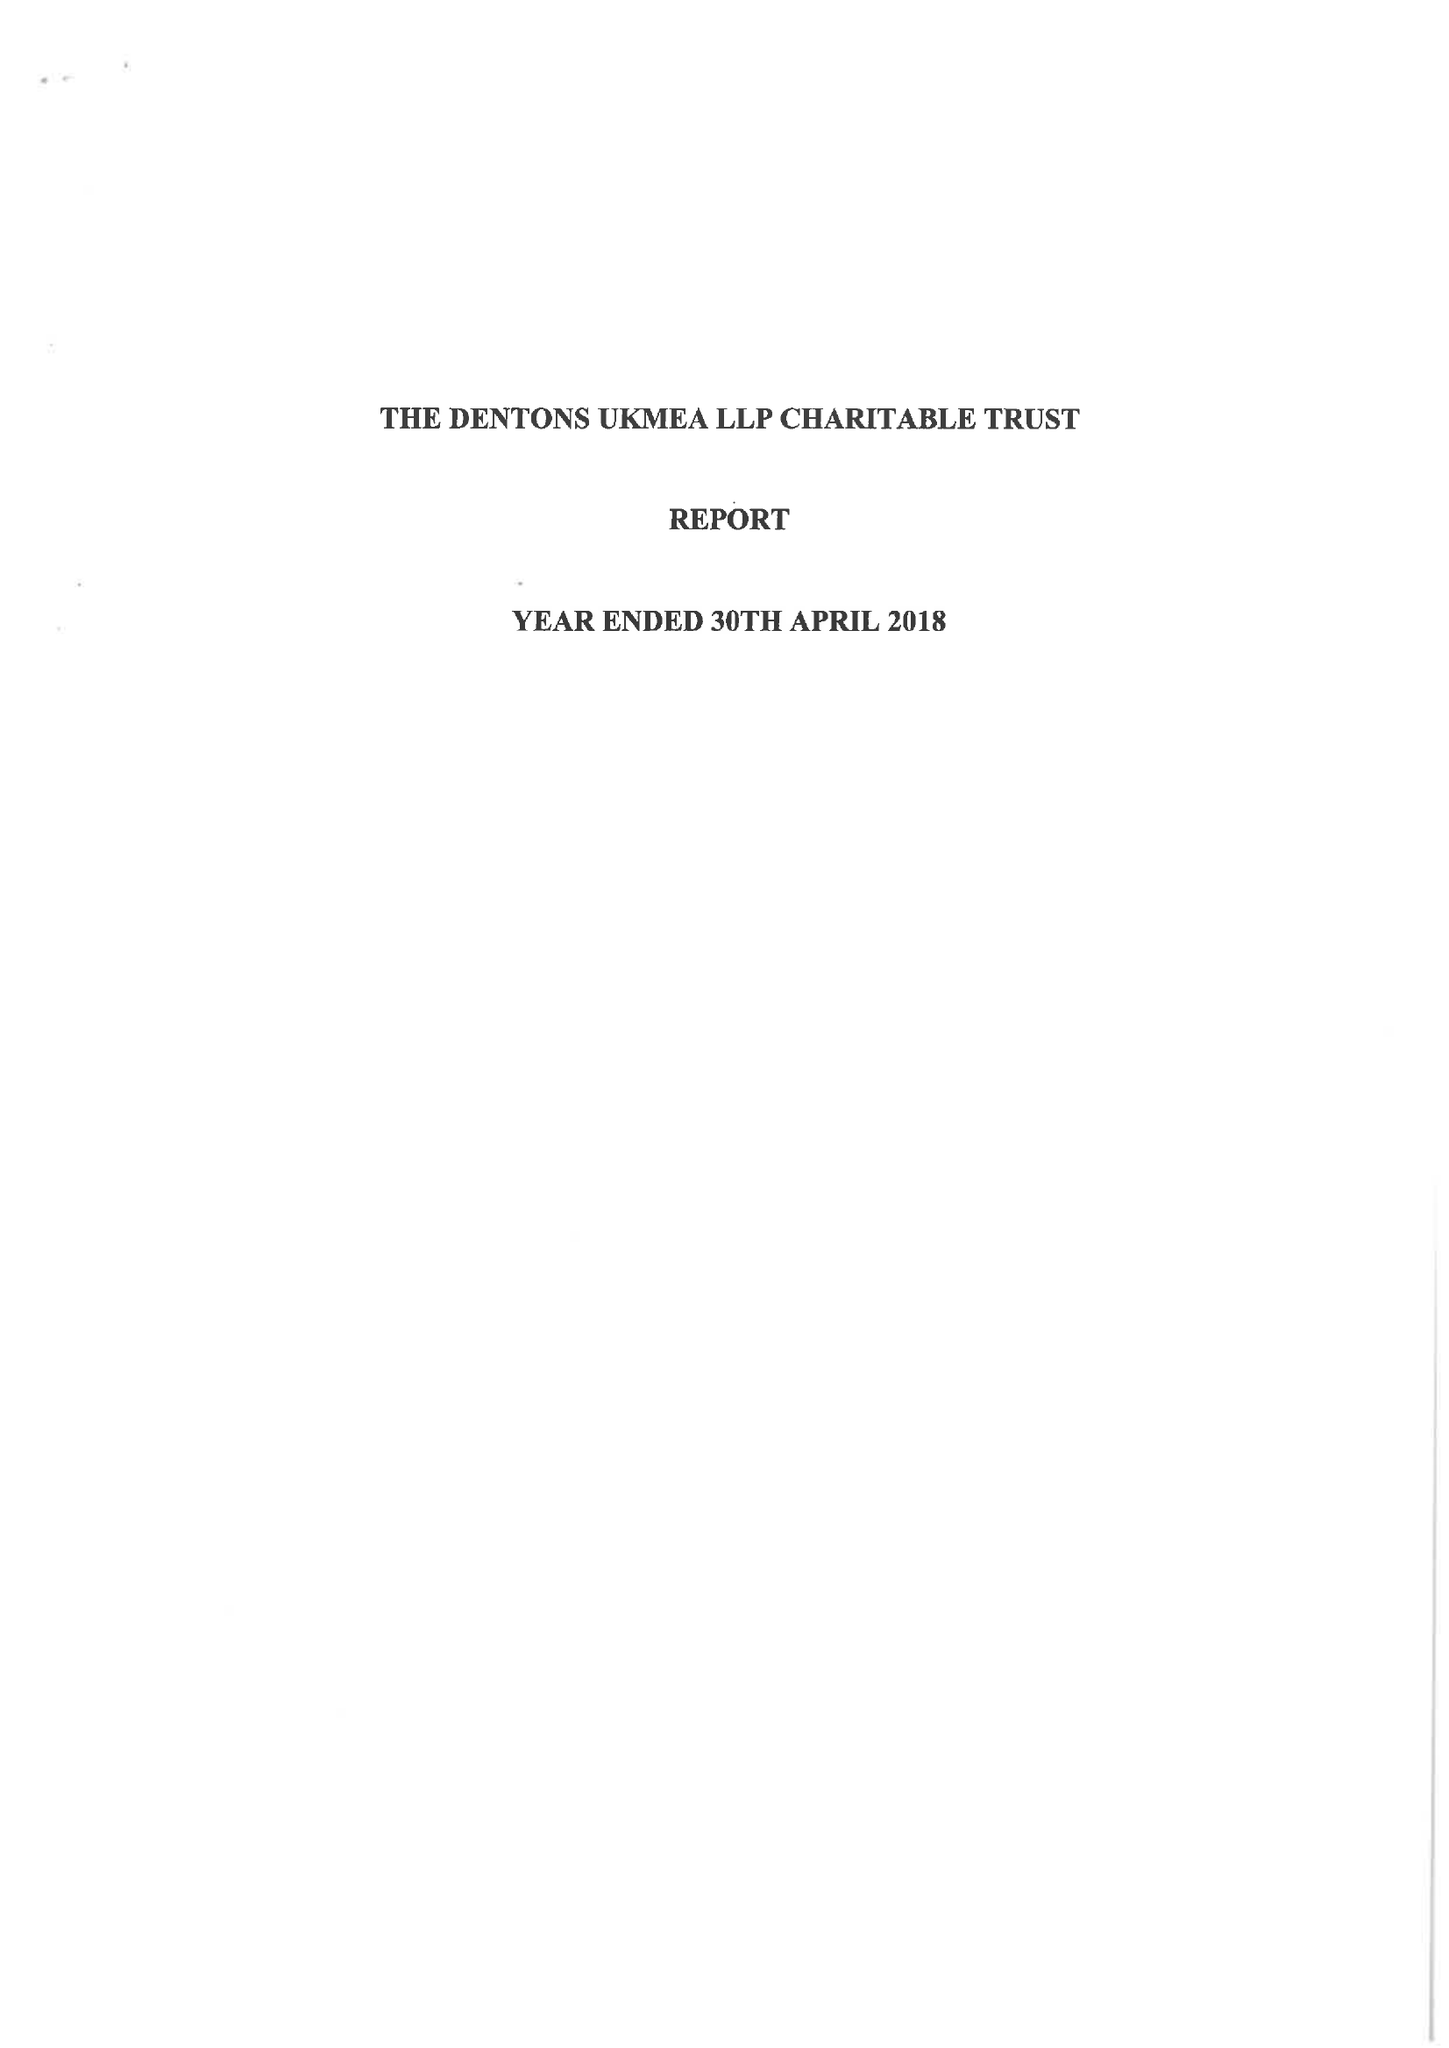What is the value for the charity_number?
Answer the question using a single word or phrase. 1041204 